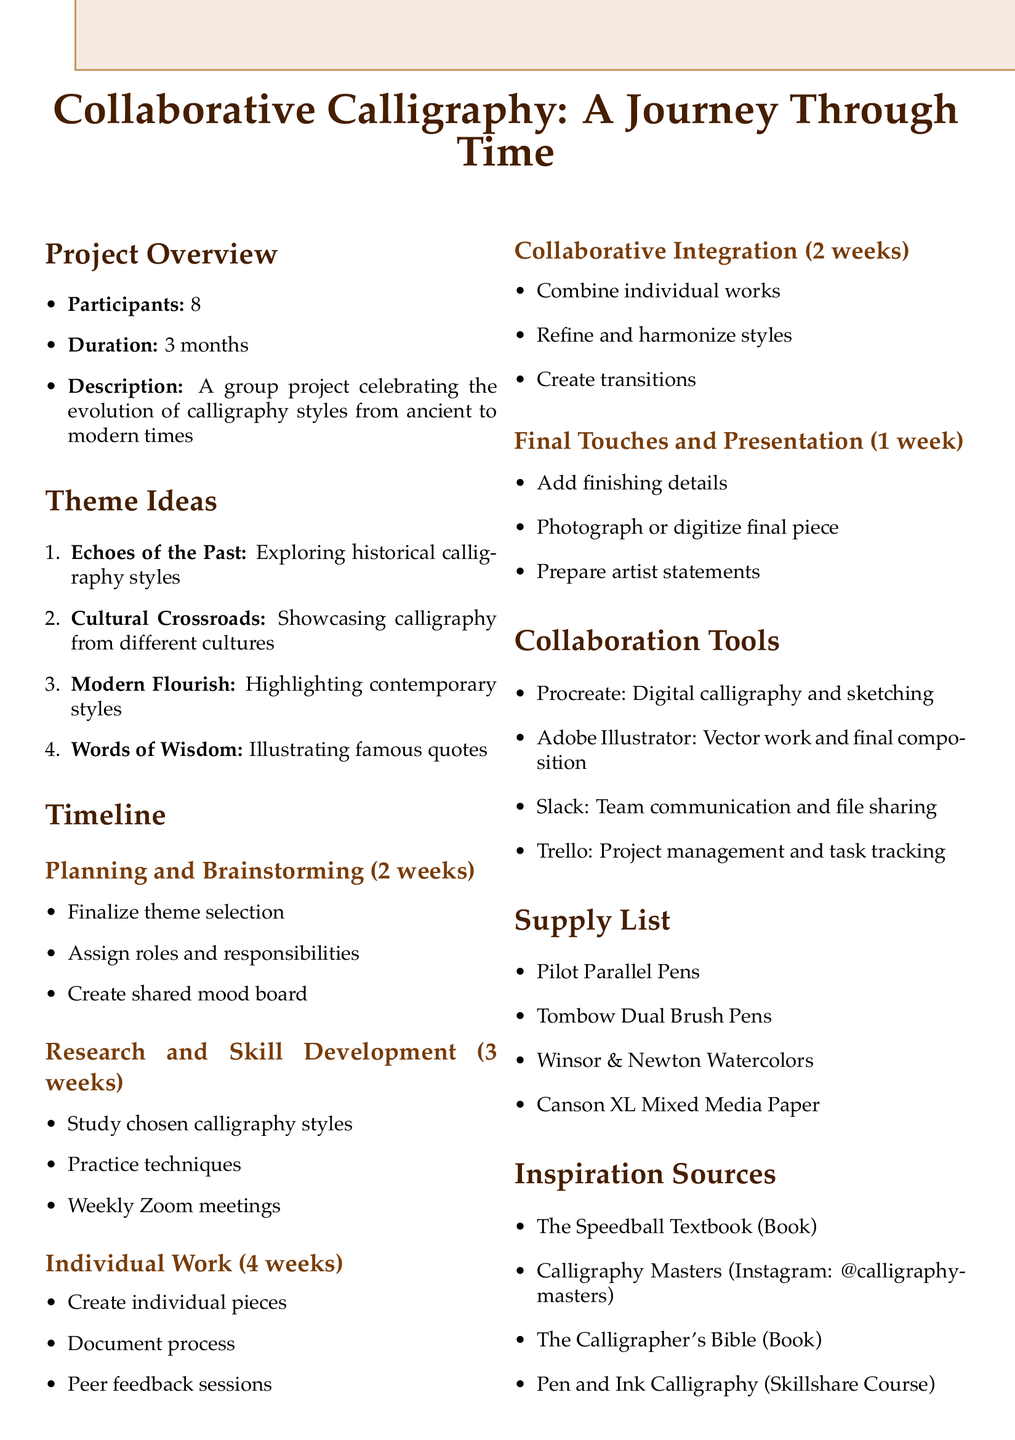What is the title of the project? The title of the project is given in the document as "Collaborative Calligraphy: A Journey Through Time."
Answer: Collaborative Calligraphy: A Journey Through Time How many participants are involved in the project? The document states that there are 8 participants in the project.
Answer: 8 What is the duration of the project? The duration of the project is mentioned in the document to be 3 months.
Answer: 3 months What is the first theme idea listed? The document lists "Echoes of the Past" as the first theme idea among the theme ideas provided.
Answer: Echoes of the Past How long is the planning phase? The document indicates that the planning phase lasts for 2 weeks.
Answer: 2 weeks Which collaboration tool is used for team communication? The document specifies that Slack is the tool used for team communication.
Answer: Slack What is the purpose of using Procreate in the project? The document describes Procreate as a tool for digital calligraphy and sketching.
Answer: Digital calligraphy and sketching How many reflection points are mentioned? The document lists a total of 4 reflection points for the project.
Answer: 4 What item is used for consistent line width in traditional styles? The document specifies "Pilot Parallel Pens" as the item used for consistent line width.
Answer: Pilot Parallel Pens 